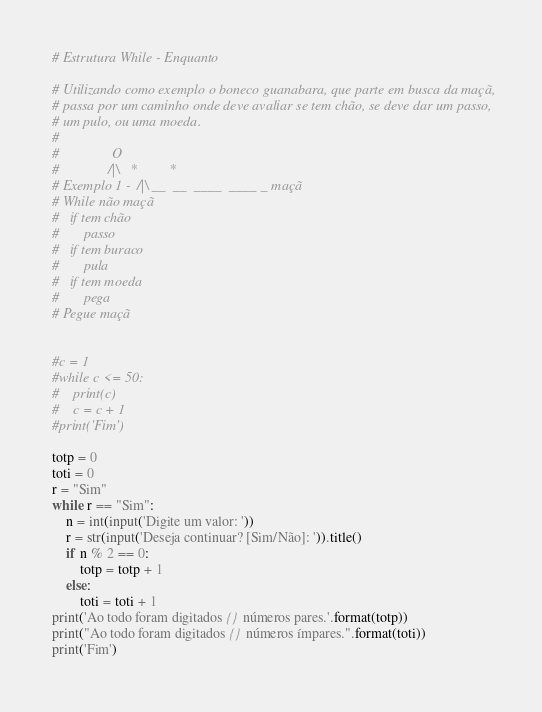Convert code to text. <code><loc_0><loc_0><loc_500><loc_500><_Python_># Estrutura While - Enquanto

# Utilizando como exemplo o boneco guanabara, que parte em busca da maçã,
# passa por um caminho onde deve avaliar se tem chão, se deve dar um passo,
# um pulo, ou uma moeda.
#
#               O
#              /|\   *         *
# Exemplo 1 -  /|\ __  __  ____  ____ _ maçã
# While não maçã
#   if tem chão
#       passo
#   if tem buraco
#       pula
#   if tem moeda
#       pega
# Pegue maçã


#c = 1
#while c <= 50:
#    print(c)
#    c = c + 1
#print('Fim')

totp = 0
toti = 0
r = "Sim"
while r == "Sim":
    n = int(input('Digite um valor: '))
    r = str(input('Deseja continuar? [Sim/Não]: ')).title()
    if n % 2 == 0:
        totp = totp + 1
    else:
        toti = toti + 1
print('Ao todo foram digitados {} números pares.'.format(totp))
print("Ao todo foram digitados {} números ímpares.".format(toti))
print('Fim')</code> 